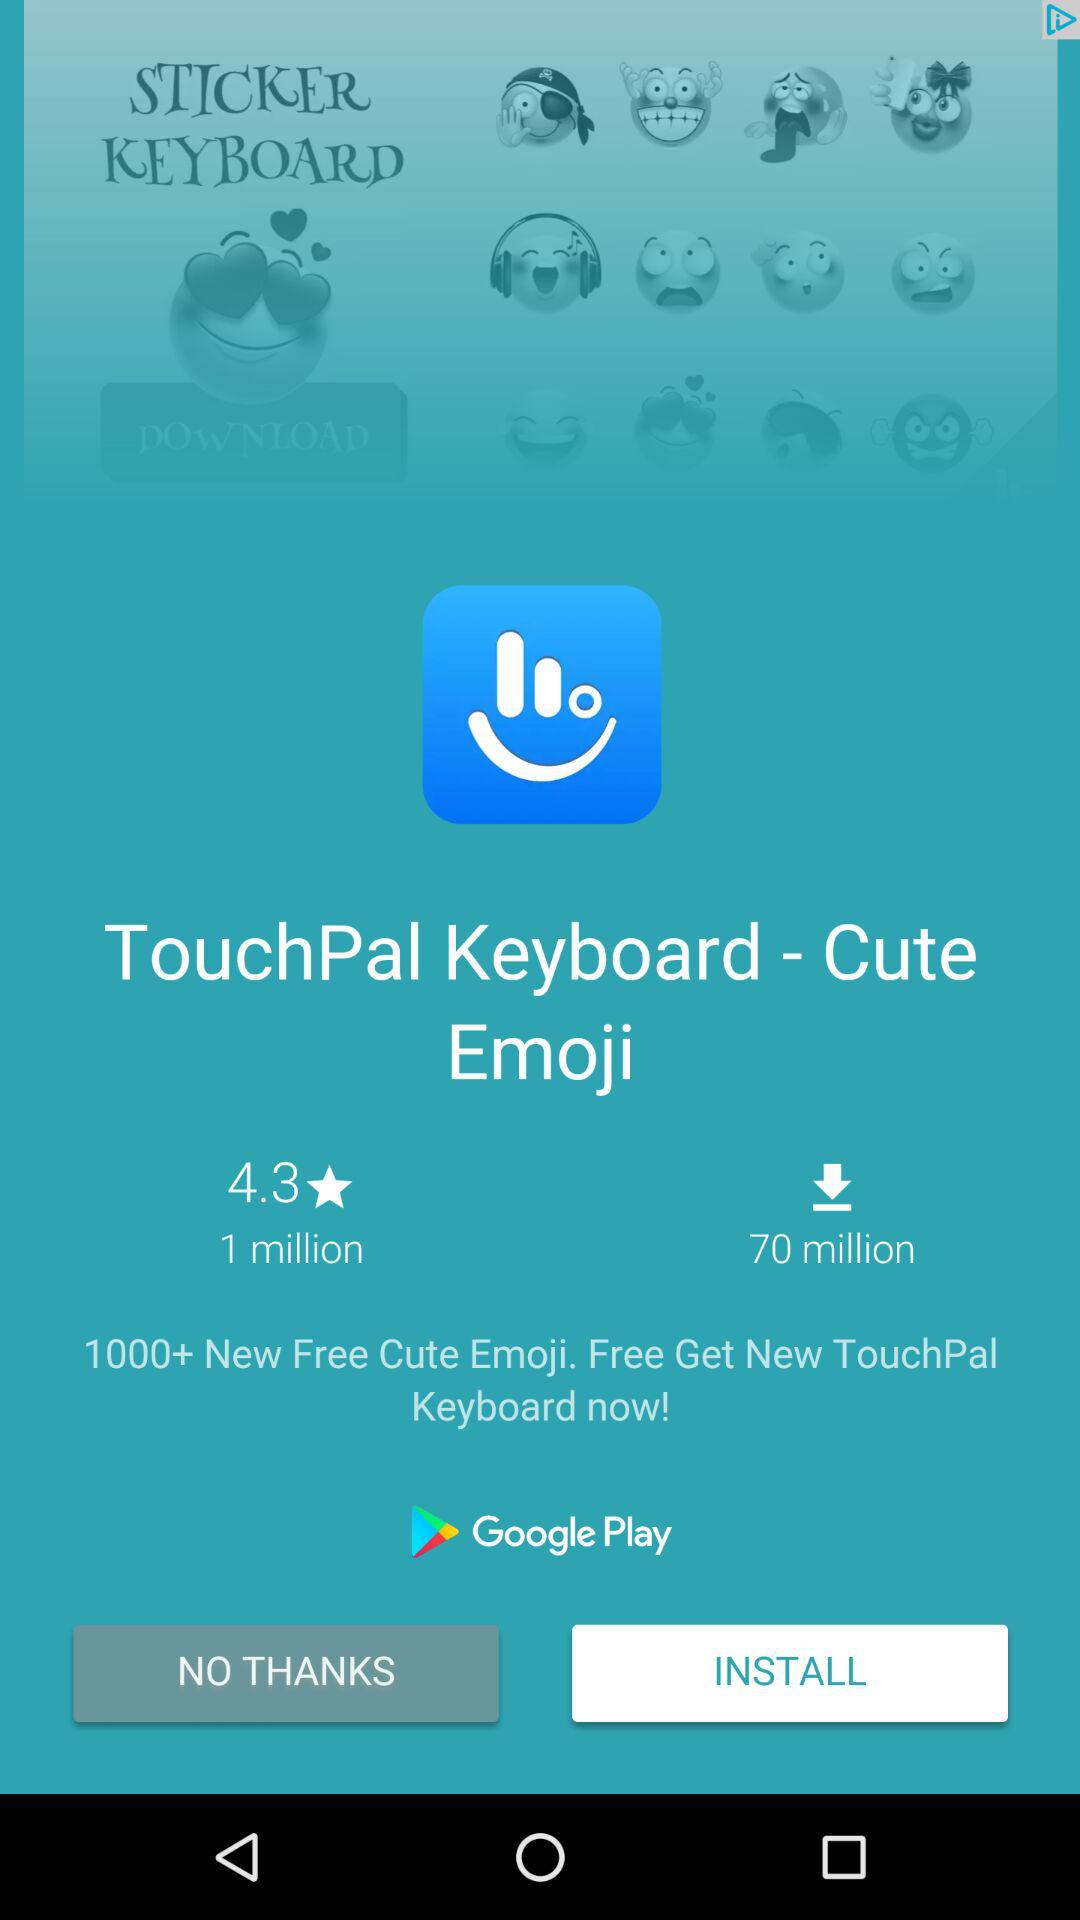How many people have rated the application? The application has been rated by 1 million people. 